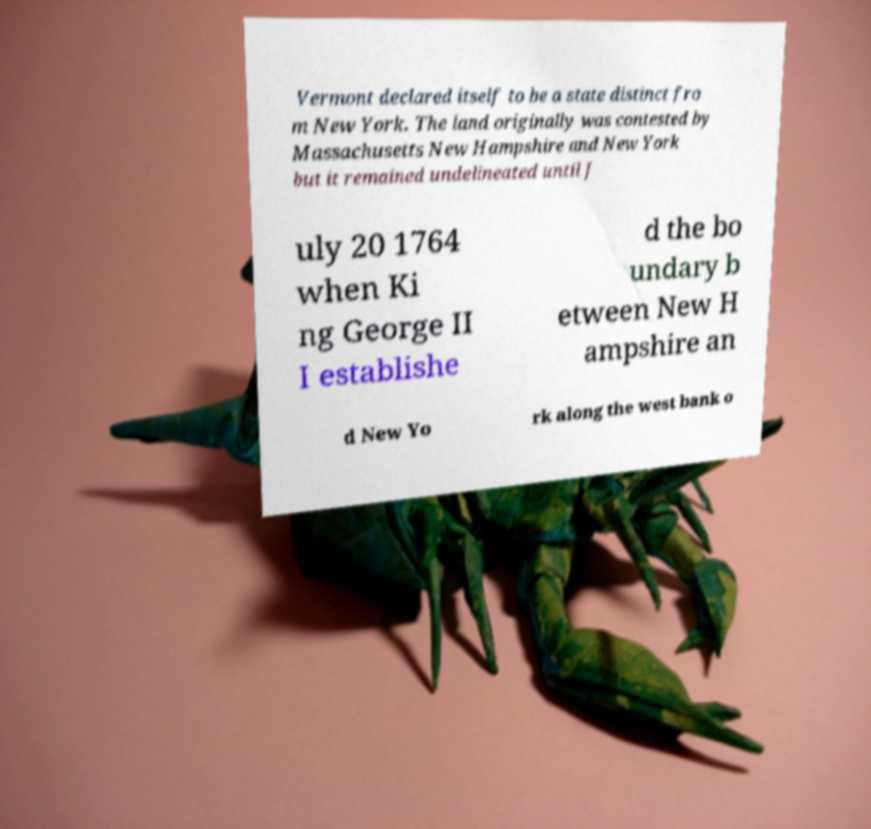Can you read and provide the text displayed in the image?This photo seems to have some interesting text. Can you extract and type it out for me? Vermont declared itself to be a state distinct fro m New York. The land originally was contested by Massachusetts New Hampshire and New York but it remained undelineated until J uly 20 1764 when Ki ng George II I establishe d the bo undary b etween New H ampshire an d New Yo rk along the west bank o 